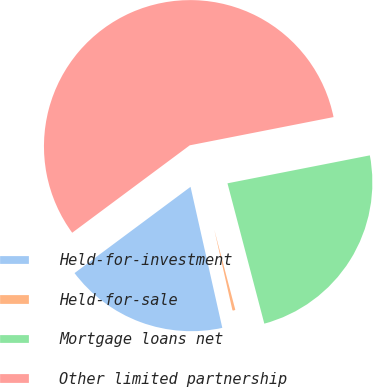Convert chart. <chart><loc_0><loc_0><loc_500><loc_500><pie_chart><fcel>Held-for-investment<fcel>Held-for-sale<fcel>Mortgage loans net<fcel>Other limited partnership<nl><fcel>18.35%<fcel>0.56%<fcel>24.0%<fcel>57.09%<nl></chart> 